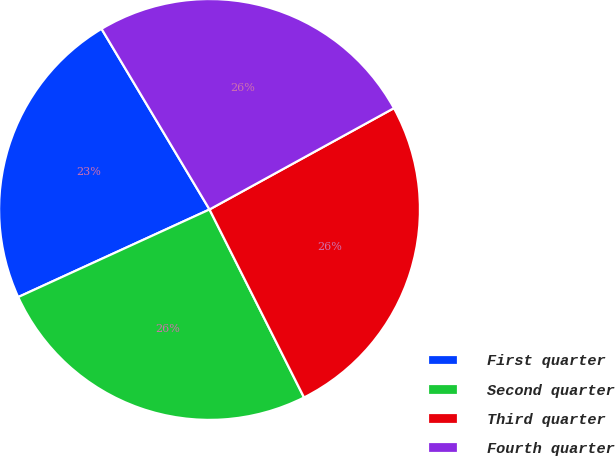Convert chart. <chart><loc_0><loc_0><loc_500><loc_500><pie_chart><fcel>First quarter<fcel>Second quarter<fcel>Third quarter<fcel>Fourth quarter<nl><fcel>23.26%<fcel>25.58%<fcel>25.58%<fcel>25.58%<nl></chart> 